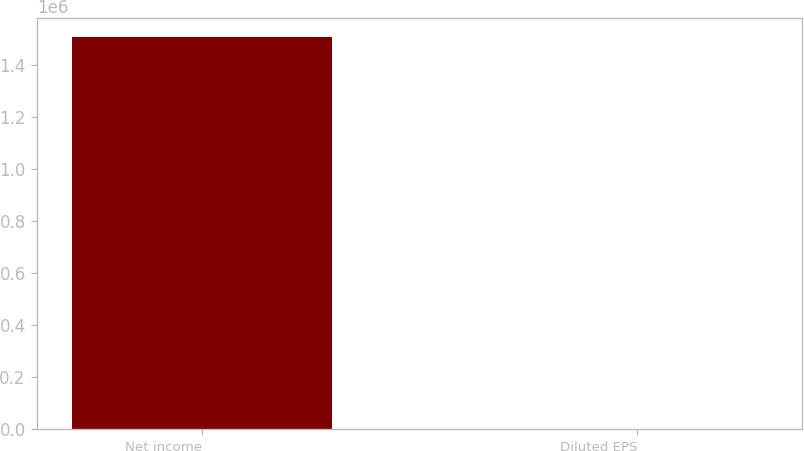<chart> <loc_0><loc_0><loc_500><loc_500><bar_chart><fcel>Net income<fcel>Diluted EPS<nl><fcel>1.50698e+06<fcel>4<nl></chart> 